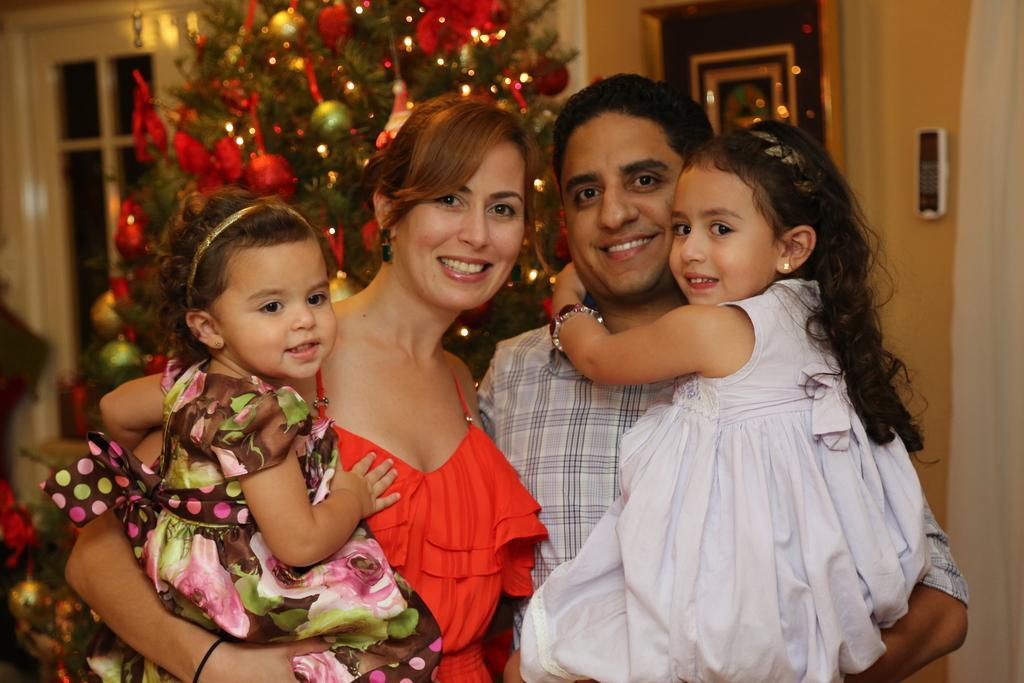How would you summarize this image in a sentence or two? In this image I can see few people and I can see smile on their faces. In the background I can see a Christmas tree and on it I can see decoration. I can also see this image is little bit blurry from background. 